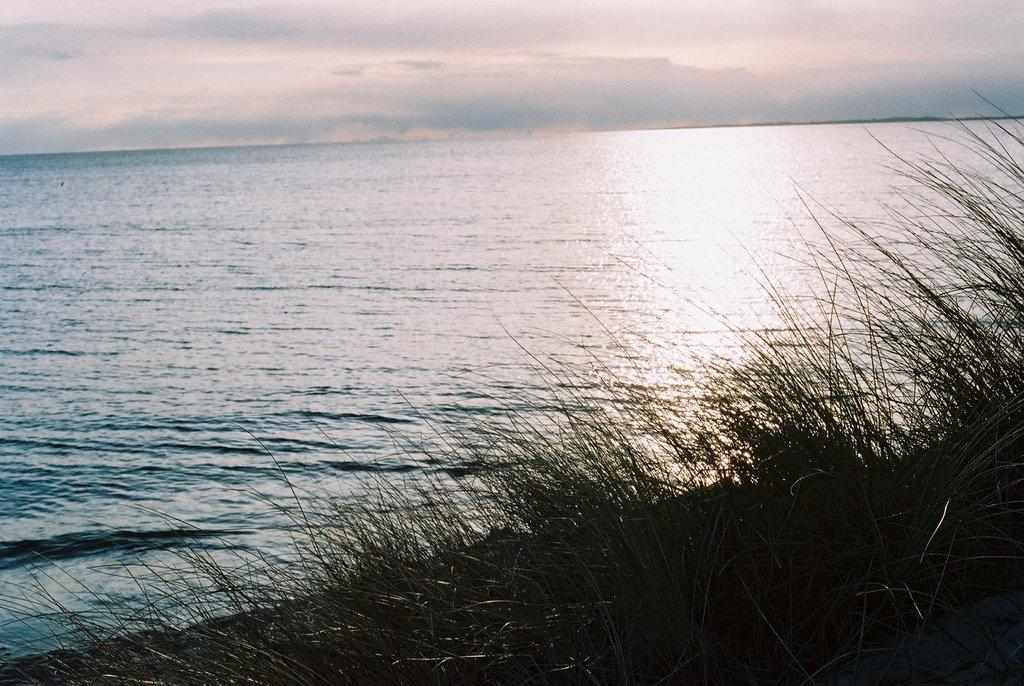What is the main feature of the image? There is an ocean in the picture. What type of vegetation is present at the bottom of the picture? There is green grass at the bottom of the picture. What can be seen in the sky in the image? There are clouds in the sky. What type of car is parked in the cellar in the image? There is no car or cellar present in the image; it features an ocean, green grass, and clouds in the sky. 